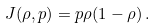<formula> <loc_0><loc_0><loc_500><loc_500>J ( \rho , p ) = p \rho ( 1 - \rho ) \, .</formula> 